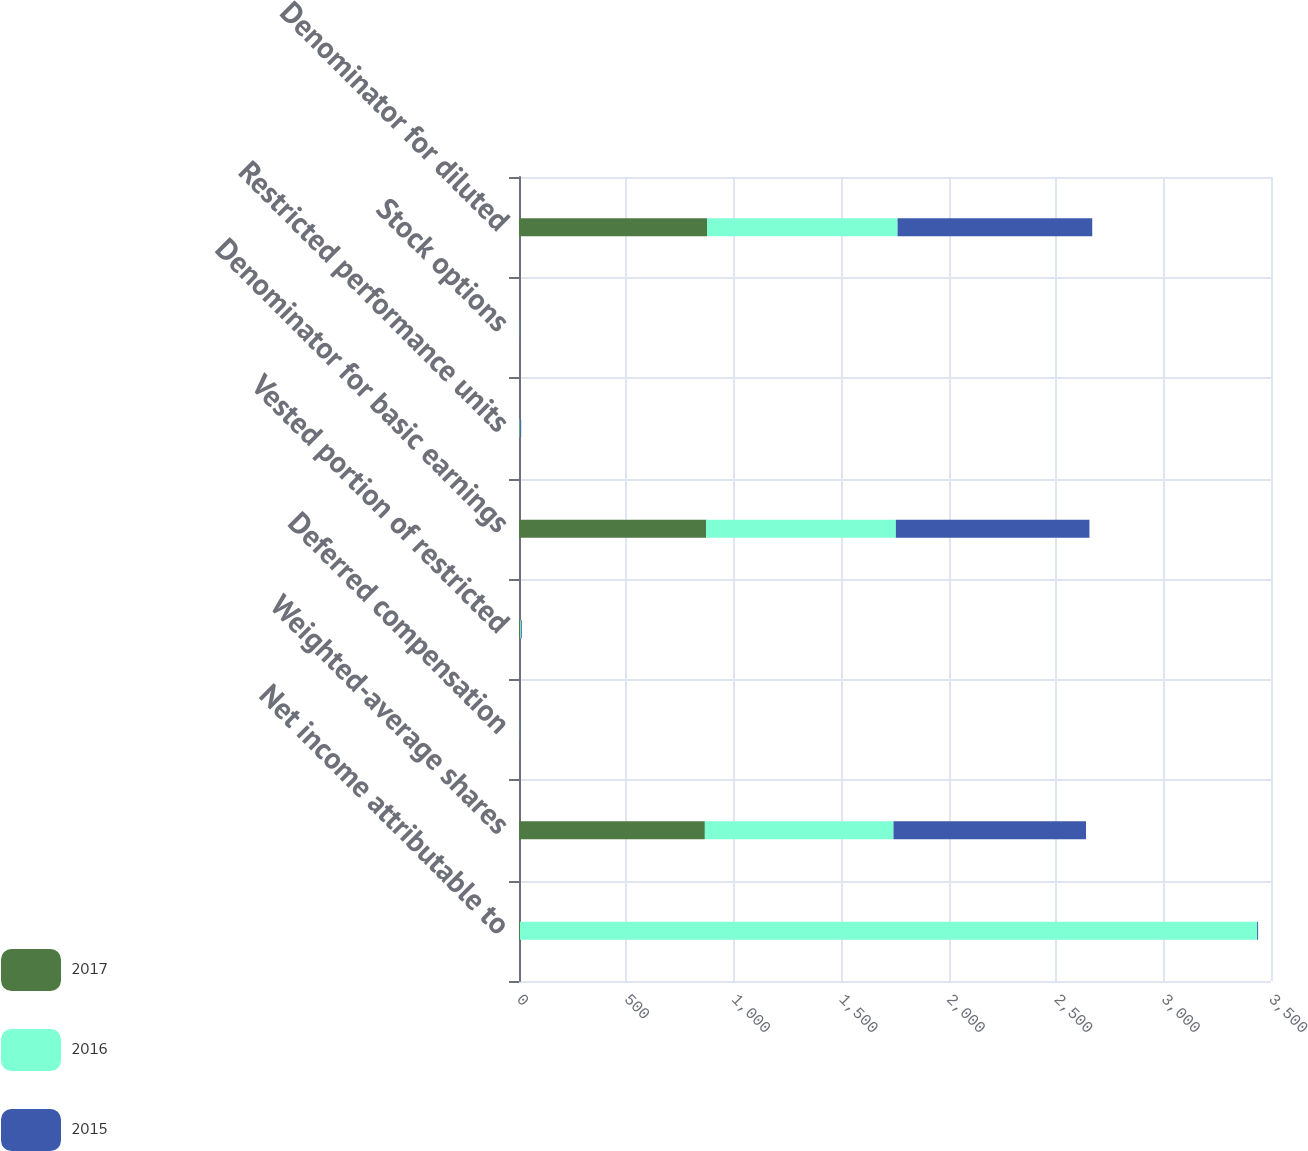Convert chart to OTSL. <chart><loc_0><loc_0><loc_500><loc_500><stacked_bar_chart><ecel><fcel>Net income attributable to<fcel>Weighted-average shares<fcel>Deferred compensation<fcel>Vested portion of restricted<fcel>Denominator for basic earnings<fcel>Restricted performance units<fcel>Stock options<fcel>Denominator for diluted<nl><fcel>2017<fcel>4.5<fcel>865<fcel>1<fcel>5<fcel>871<fcel>3<fcel>1<fcel>875<nl><fcel>2016<fcel>3431<fcel>878<fcel>1<fcel>4<fcel>883<fcel>3<fcel>1<fcel>887<nl><fcel>2015<fcel>4.5<fcel>896<fcel>1<fcel>4<fcel>901<fcel>4<fcel>1<fcel>906<nl></chart> 